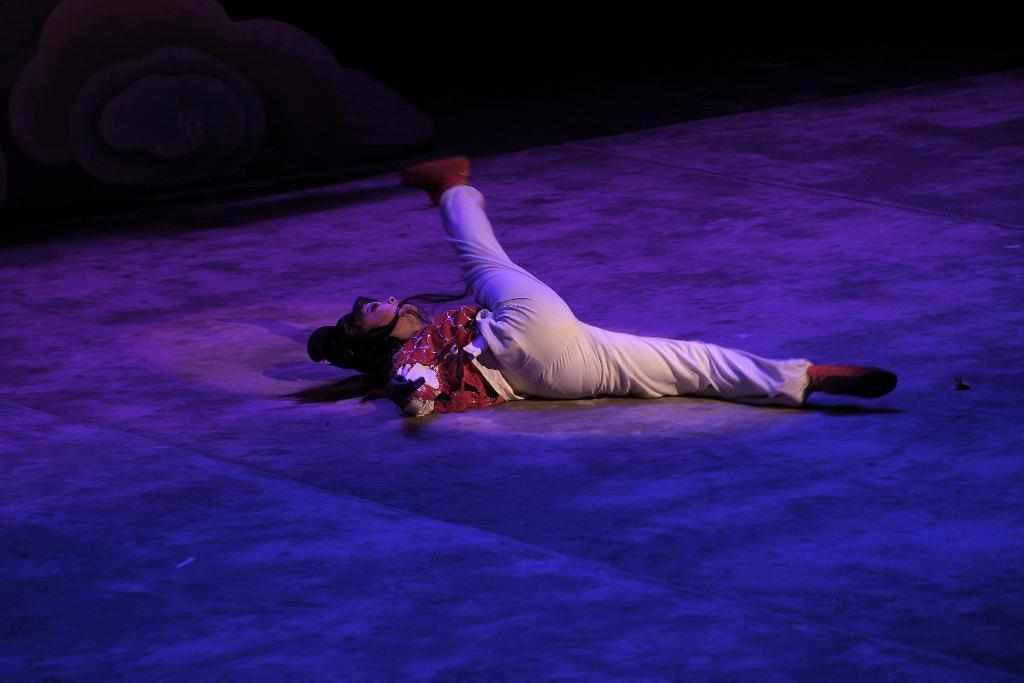Could you give a brief overview of what you see in this image? In this image we can see a lady lying on the floor. The background of the image is not clear. 